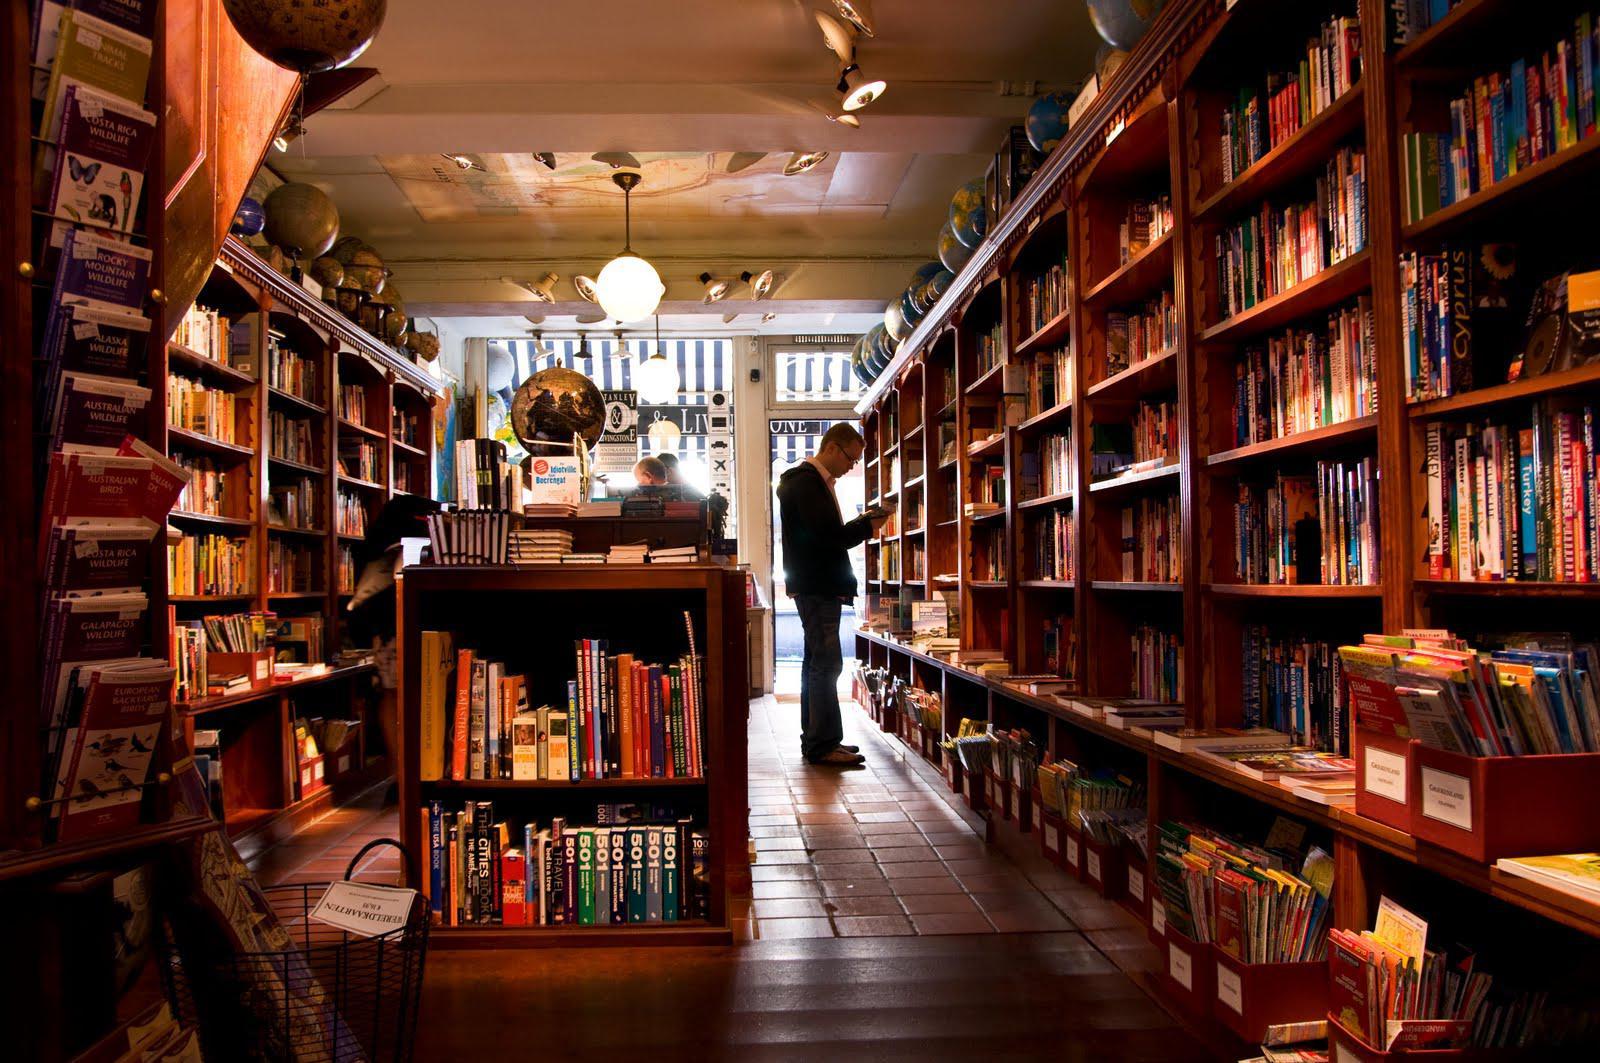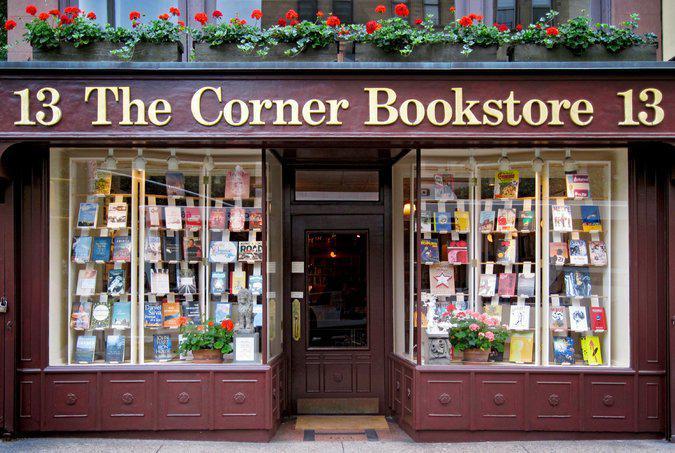The first image is the image on the left, the second image is the image on the right. For the images displayed, is the sentence "There is at least one person in the image on the left." factually correct? Answer yes or no. Yes. 